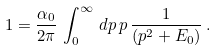<formula> <loc_0><loc_0><loc_500><loc_500>1 = \frac { \alpha _ { 0 } } { 2 \pi } \, \int _ { 0 } ^ { \infty } \, d p \, p \, \frac { 1 } { ( p ^ { 2 } + E _ { 0 } ) } \, .</formula> 